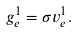<formula> <loc_0><loc_0><loc_500><loc_500>g _ { e } ^ { 1 } = \sigma v _ { e } ^ { 1 } .</formula> 